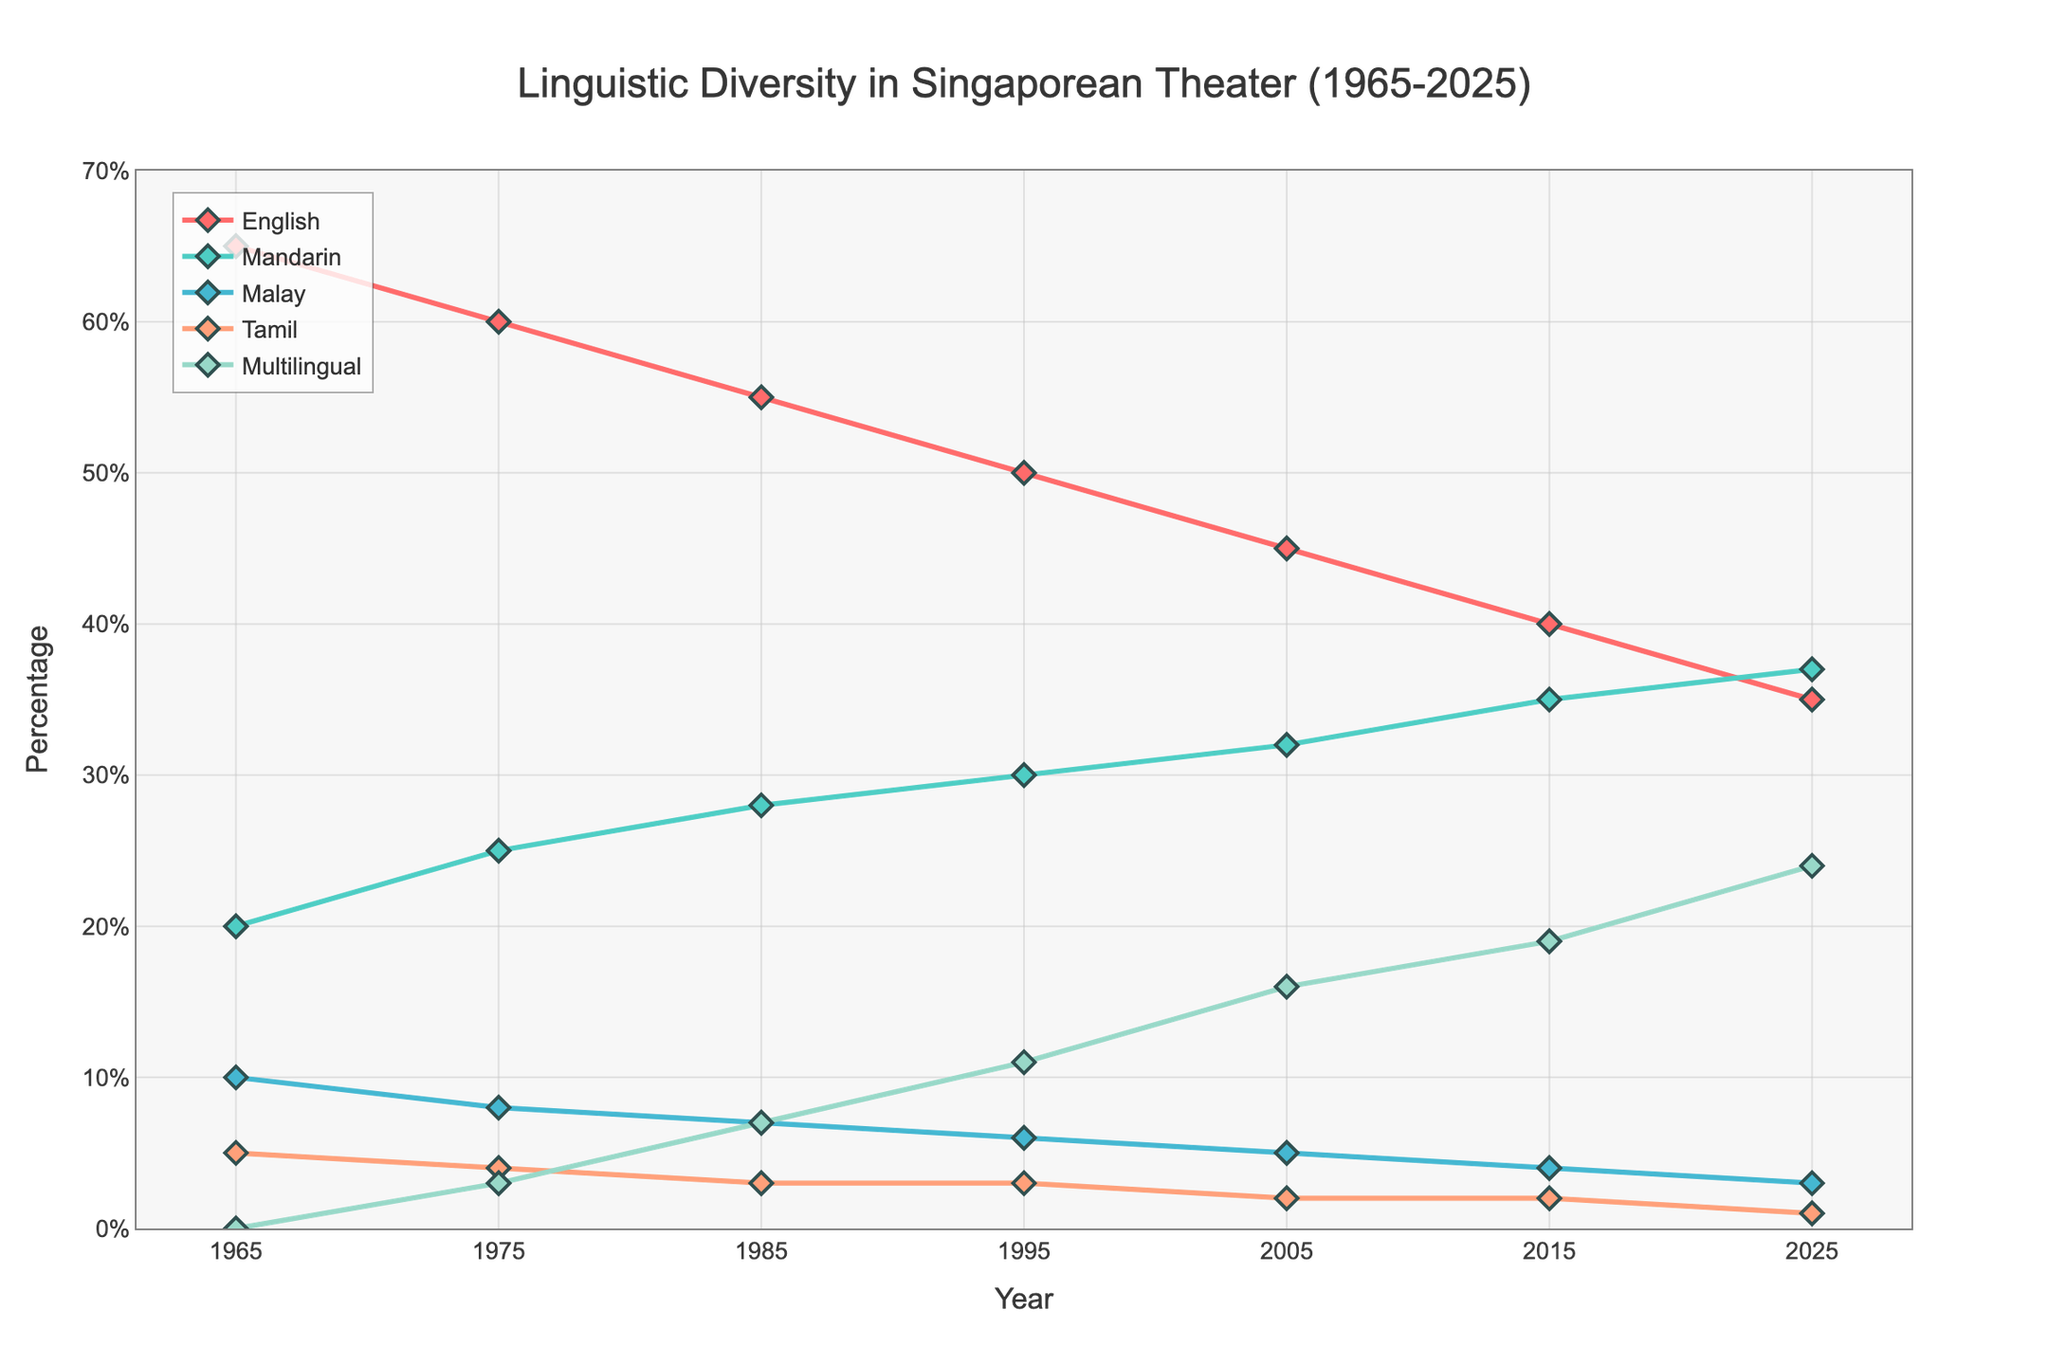How many languages are tracked in the chart from 1965 to 2025? Count the number of different linguistic categories in the chart. We see English, Mandarin, Malay, Tamil, and Multilingual, which totals to five categories.
Answer: 5 Which language saw the largest increase in its percentage share from 1965 to 2025? Compare the percentage share of each language in 1965 to that in 2025. English decreased from 65% to 35%, Mandarin increased from 20% to 37%, Malay decreased from 10% to 3%, Tamil decreased from 5% to 1%, and Multilingual increased from 0% to 24%. The largest increase is in the Multilingual category.
Answer: Multilingual In which year did Mandarin surpass English in percentage share? Check the trend lines for Mandarin and English. Mandarin surpasses English between 2015 and 2025. Reviewing these years, Mandarin is higher than English in 2025.
Answer: 2025 What is the total percentage of Malay and Tamil theatre productions in 1995? Add the percentages of Malay and Tamil in 1995. Malay is 6% and Tamil is 3%, making the total 6% + 3% = 9%.
Answer: 9% By how much did the percentage of English theatre productions decrease from 1965 to 2015? Subtract the percentage of English theatre productions in 2015 from that in 1965. The values are 65% in 1965 and 40% in 2015, so the decrement is 65% - 40% = 25%.
Answer: 25% Which color represents the Multilingual category in the chart? Refer to the chart to identify the color associated with the Multilingual line. The color is a shade of green.
Answer: Green In which decade did Tamil theatre productions experience the first decline in their percentage share? Observe the trend for Tamil productions for each decade. Between 1965 and 1975, Tamil productions decreased from 5% to 4%, marking the first decline.
Answer: 1970s What is the average percentage share of English theatre productions over the years presented? Calculate the sum of the percentages for English and then divide by the number of years. The percentages are 65, 60, 55, 50, 45, 40, 35. Summing these gives 350, and dividing by 7 years gives 350 / 7 ≈ 50%.
Answer: 50% Between which consecutive decades did Multilingual theatre productions see the largest increase? Calculate the increase in percentage for consecutive decades: 
- 1965-1975: 3% - 0% = 3%
- 1975-1985: 7% - 3% = 4%
- 1985-1995: 11% - 7% = 4%
- 1995-2005: 16% - 11% = 5%
- 2005-2015: 19% - 16% = 3%
- 2015-2025: 24% - 19% = 5%
Thus, the largest increases are between 1995-2005 and 2015-2025, both with 5%.
Answer: 1995-2005 and 2015-2025 